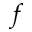Convert formula to latex. <formula><loc_0><loc_0><loc_500><loc_500>f</formula> 